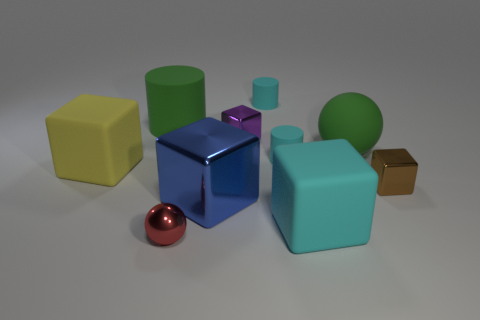What can be said about the lighting and shadows in the scene? The lighting in the image is diffused, with shadows indicating a light source coming from the upper right-hand side, which subtly enhances the textures and the three-dimensionality of the objects. 